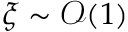<formula> <loc_0><loc_0><loc_500><loc_500>\xi \sim \mathcal { O } ( 1 )</formula> 